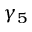Convert formula to latex. <formula><loc_0><loc_0><loc_500><loc_500>\gamma _ { 5 }</formula> 